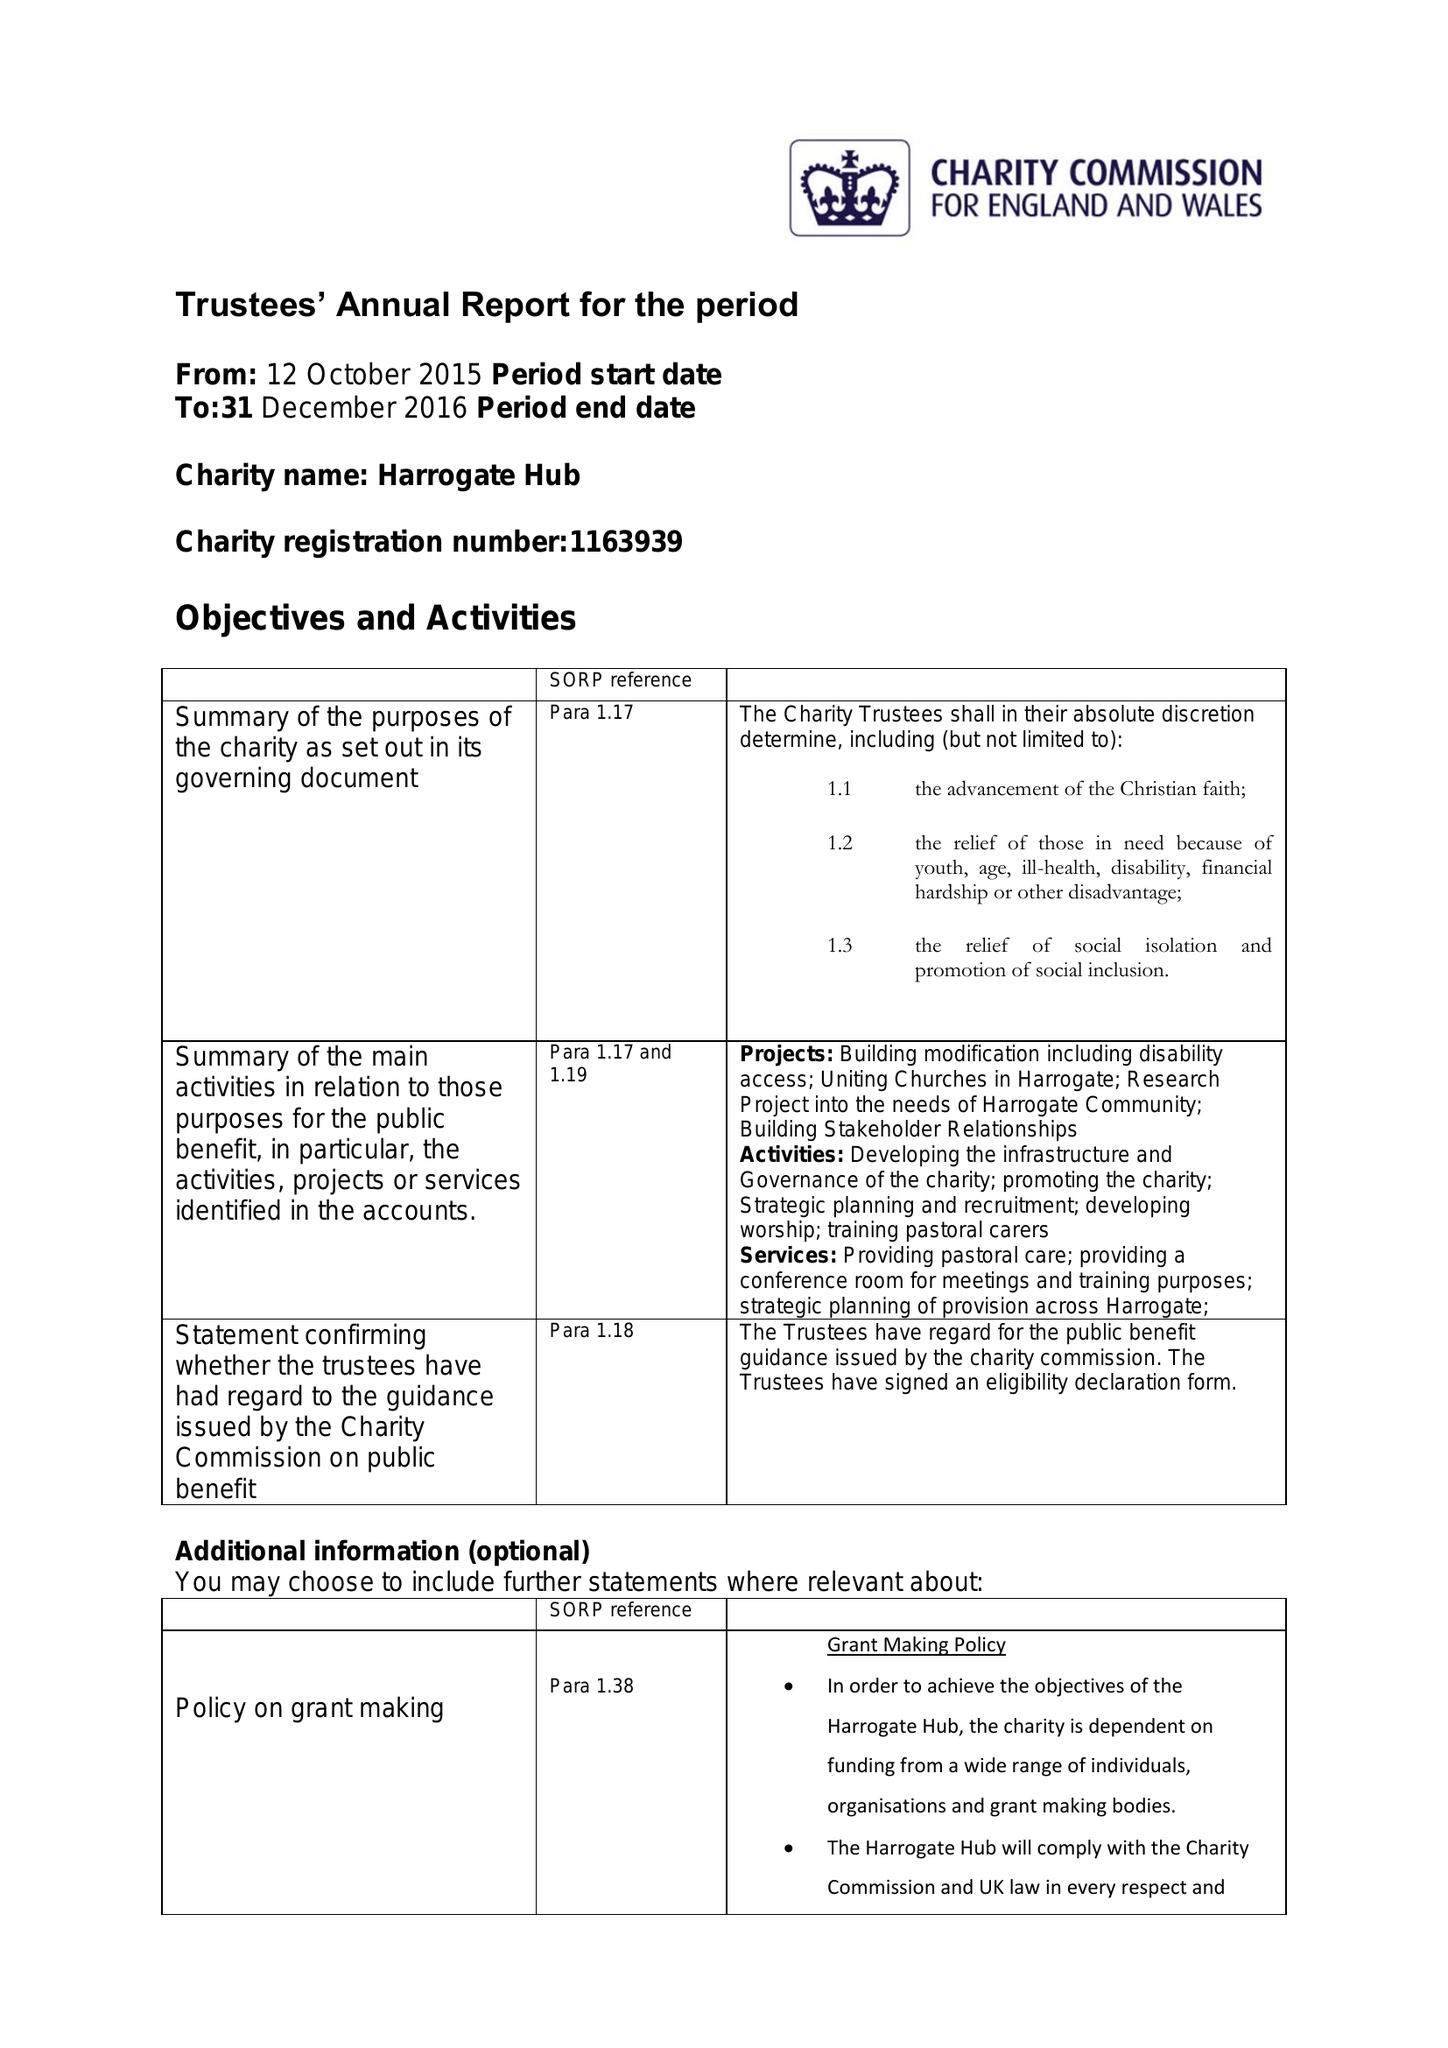What is the value for the address__post_town?
Answer the question using a single word or phrase. HARROGATE 